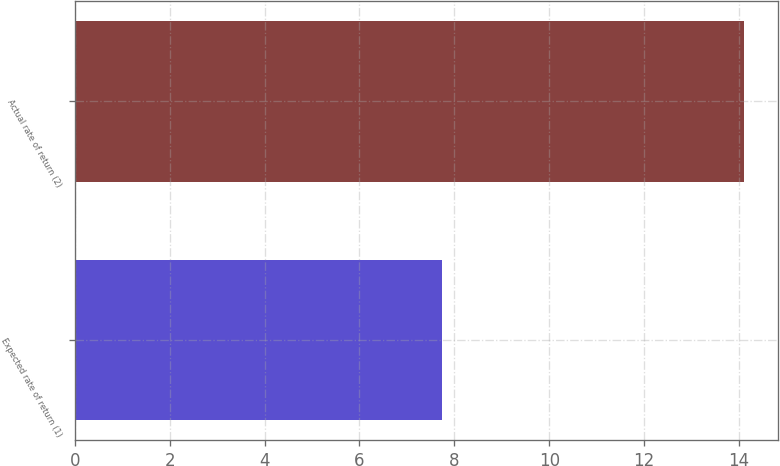<chart> <loc_0><loc_0><loc_500><loc_500><bar_chart><fcel>Expected rate of return (1)<fcel>Actual rate of return (2)<nl><fcel>7.75<fcel>14.11<nl></chart> 